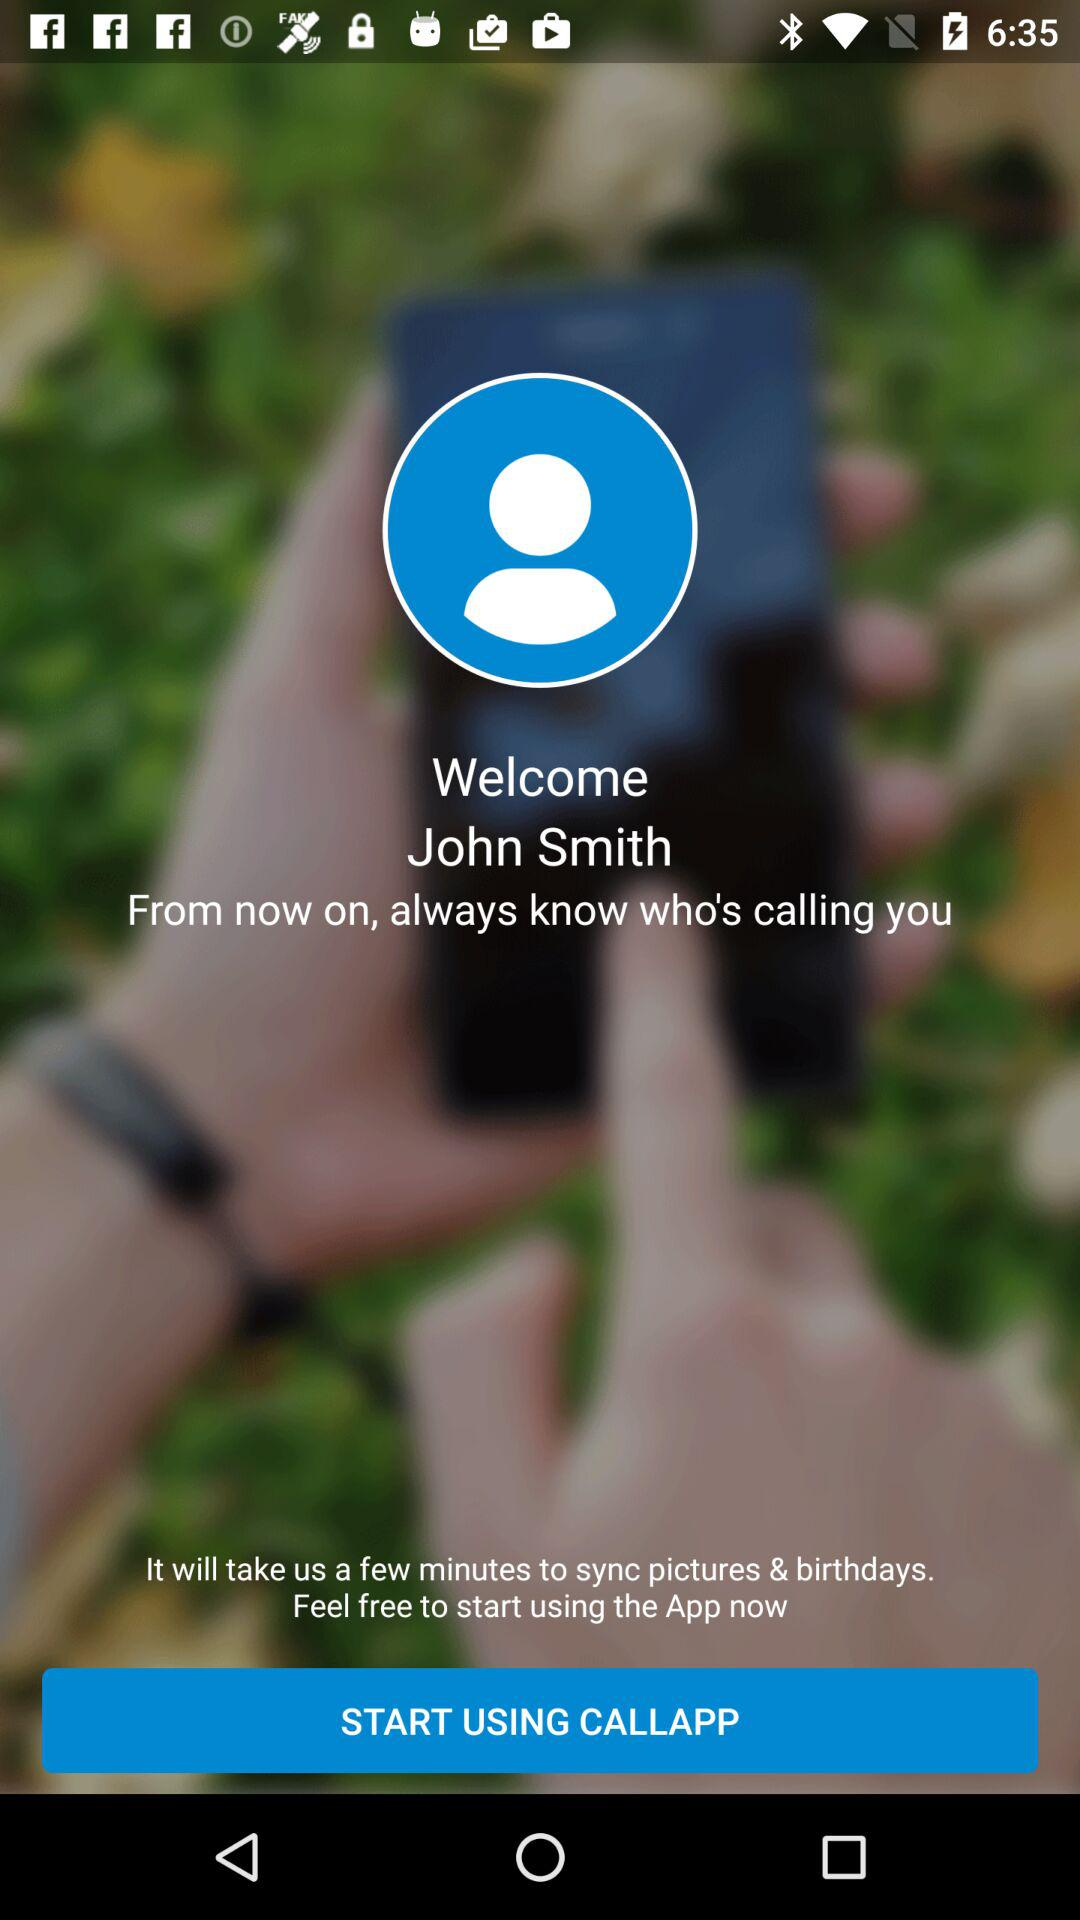What is the user name? The user name is John Smith. 